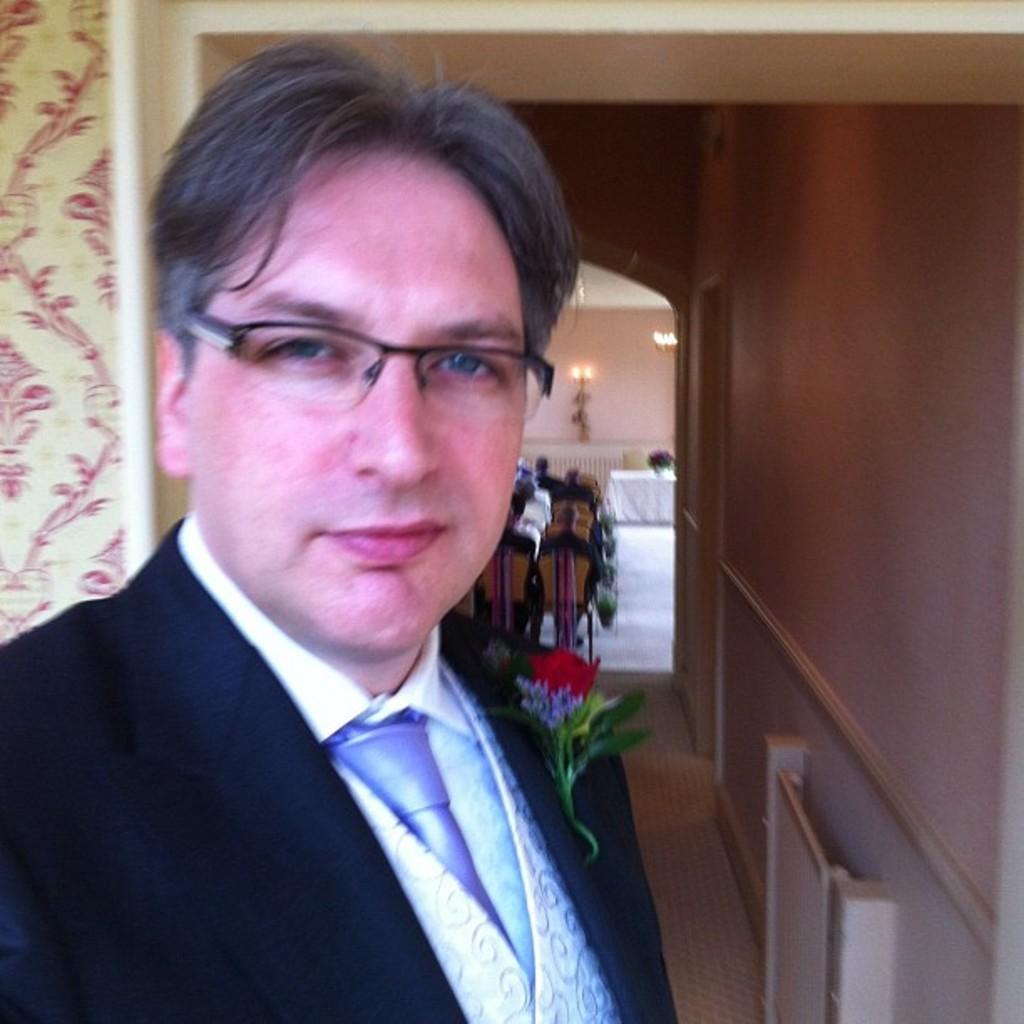Describe this image in one or two sentences. In this picture we can see a man in the blazer and behind the man there are some people sitting on chairs and a wall with a light. 